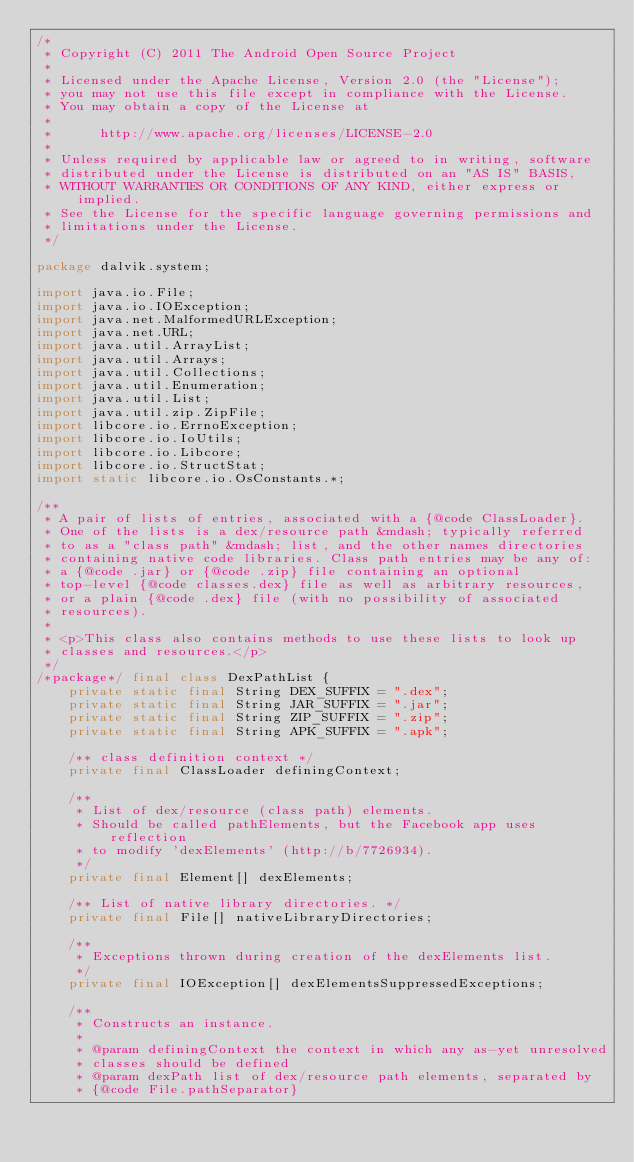<code> <loc_0><loc_0><loc_500><loc_500><_Java_>/*
 * Copyright (C) 2011 The Android Open Source Project
 *
 * Licensed under the Apache License, Version 2.0 (the "License");
 * you may not use this file except in compliance with the License.
 * You may obtain a copy of the License at
 *
 *      http://www.apache.org/licenses/LICENSE-2.0
 *
 * Unless required by applicable law or agreed to in writing, software
 * distributed under the License is distributed on an "AS IS" BASIS,
 * WITHOUT WARRANTIES OR CONDITIONS OF ANY KIND, either express or implied.
 * See the License for the specific language governing permissions and
 * limitations under the License.
 */

package dalvik.system;

import java.io.File;
import java.io.IOException;
import java.net.MalformedURLException;
import java.net.URL;
import java.util.ArrayList;
import java.util.Arrays;
import java.util.Collections;
import java.util.Enumeration;
import java.util.List;
import java.util.zip.ZipFile;
import libcore.io.ErrnoException;
import libcore.io.IoUtils;
import libcore.io.Libcore;
import libcore.io.StructStat;
import static libcore.io.OsConstants.*;

/**
 * A pair of lists of entries, associated with a {@code ClassLoader}.
 * One of the lists is a dex/resource path &mdash; typically referred
 * to as a "class path" &mdash; list, and the other names directories
 * containing native code libraries. Class path entries may be any of:
 * a {@code .jar} or {@code .zip} file containing an optional
 * top-level {@code classes.dex} file as well as arbitrary resources,
 * or a plain {@code .dex} file (with no possibility of associated
 * resources).
 *
 * <p>This class also contains methods to use these lists to look up
 * classes and resources.</p>
 */
/*package*/ final class DexPathList {
    private static final String DEX_SUFFIX = ".dex";
    private static final String JAR_SUFFIX = ".jar";
    private static final String ZIP_SUFFIX = ".zip";
    private static final String APK_SUFFIX = ".apk";

    /** class definition context */
    private final ClassLoader definingContext;

    /**
     * List of dex/resource (class path) elements.
     * Should be called pathElements, but the Facebook app uses reflection
     * to modify 'dexElements' (http://b/7726934).
     */
    private final Element[] dexElements;

    /** List of native library directories. */
    private final File[] nativeLibraryDirectories;

    /**
     * Exceptions thrown during creation of the dexElements list.
     */
    private final IOException[] dexElementsSuppressedExceptions;

    /**
     * Constructs an instance.
     *
     * @param definingContext the context in which any as-yet unresolved
     * classes should be defined
     * @param dexPath list of dex/resource path elements, separated by
     * {@code File.pathSeparator}</code> 